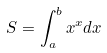<formula> <loc_0><loc_0><loc_500><loc_500>S = \int _ { a } ^ { b } x ^ { x } d x</formula> 